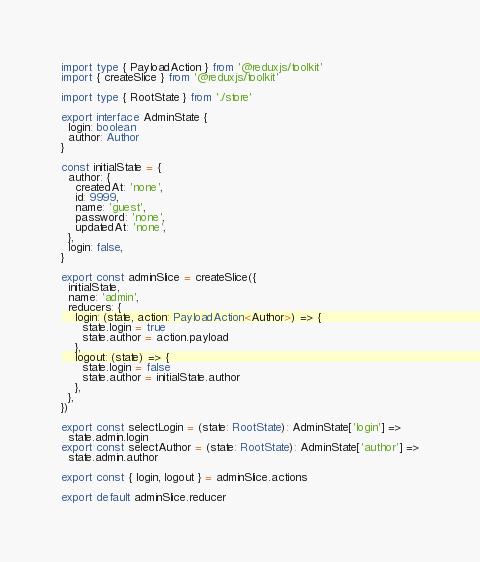Convert code to text. <code><loc_0><loc_0><loc_500><loc_500><_TypeScript_>import type { PayloadAction } from '@reduxjs/toolkit'
import { createSlice } from '@reduxjs/toolkit'

import type { RootState } from './store'

export interface AdminState {
  login: boolean
  author: Author
}

const initialState = {
  author: {
    createdAt: 'none',
    id: 9999,
    name: 'guest',
    password: 'none',
    updatedAt: 'none',
  },
  login: false,
}

export const adminSlice = createSlice({
  initialState,
  name: 'admin',
  reducers: {
    login: (state, action: PayloadAction<Author>) => {
      state.login = true
      state.author = action.payload
    },
    logout: (state) => {
      state.login = false
      state.author = initialState.author
    },
  },
})

export const selectLogin = (state: RootState): AdminState['login'] =>
  state.admin.login
export const selectAuthor = (state: RootState): AdminState['author'] =>
  state.admin.author

export const { login, logout } = adminSlice.actions

export default adminSlice.reducer
</code> 